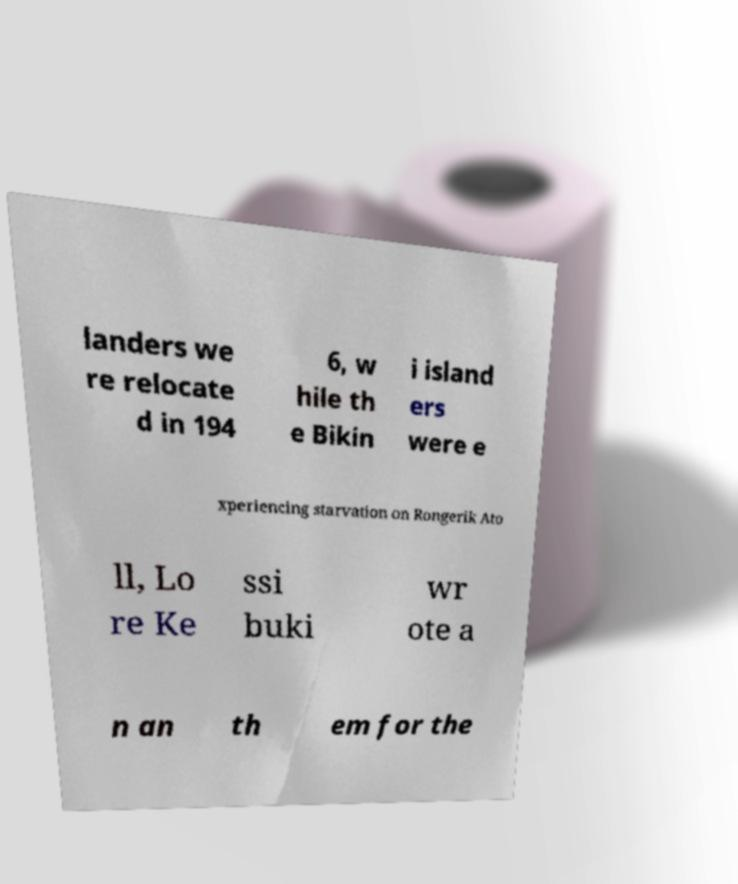Could you assist in decoding the text presented in this image and type it out clearly? landers we re relocate d in 194 6, w hile th e Bikin i island ers were e xperiencing starvation on Rongerik Ato ll, Lo re Ke ssi buki wr ote a n an th em for the 